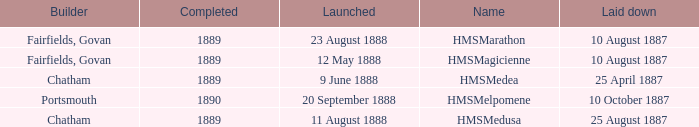What boat was laid down on 25 april 1887? HMSMedea. 